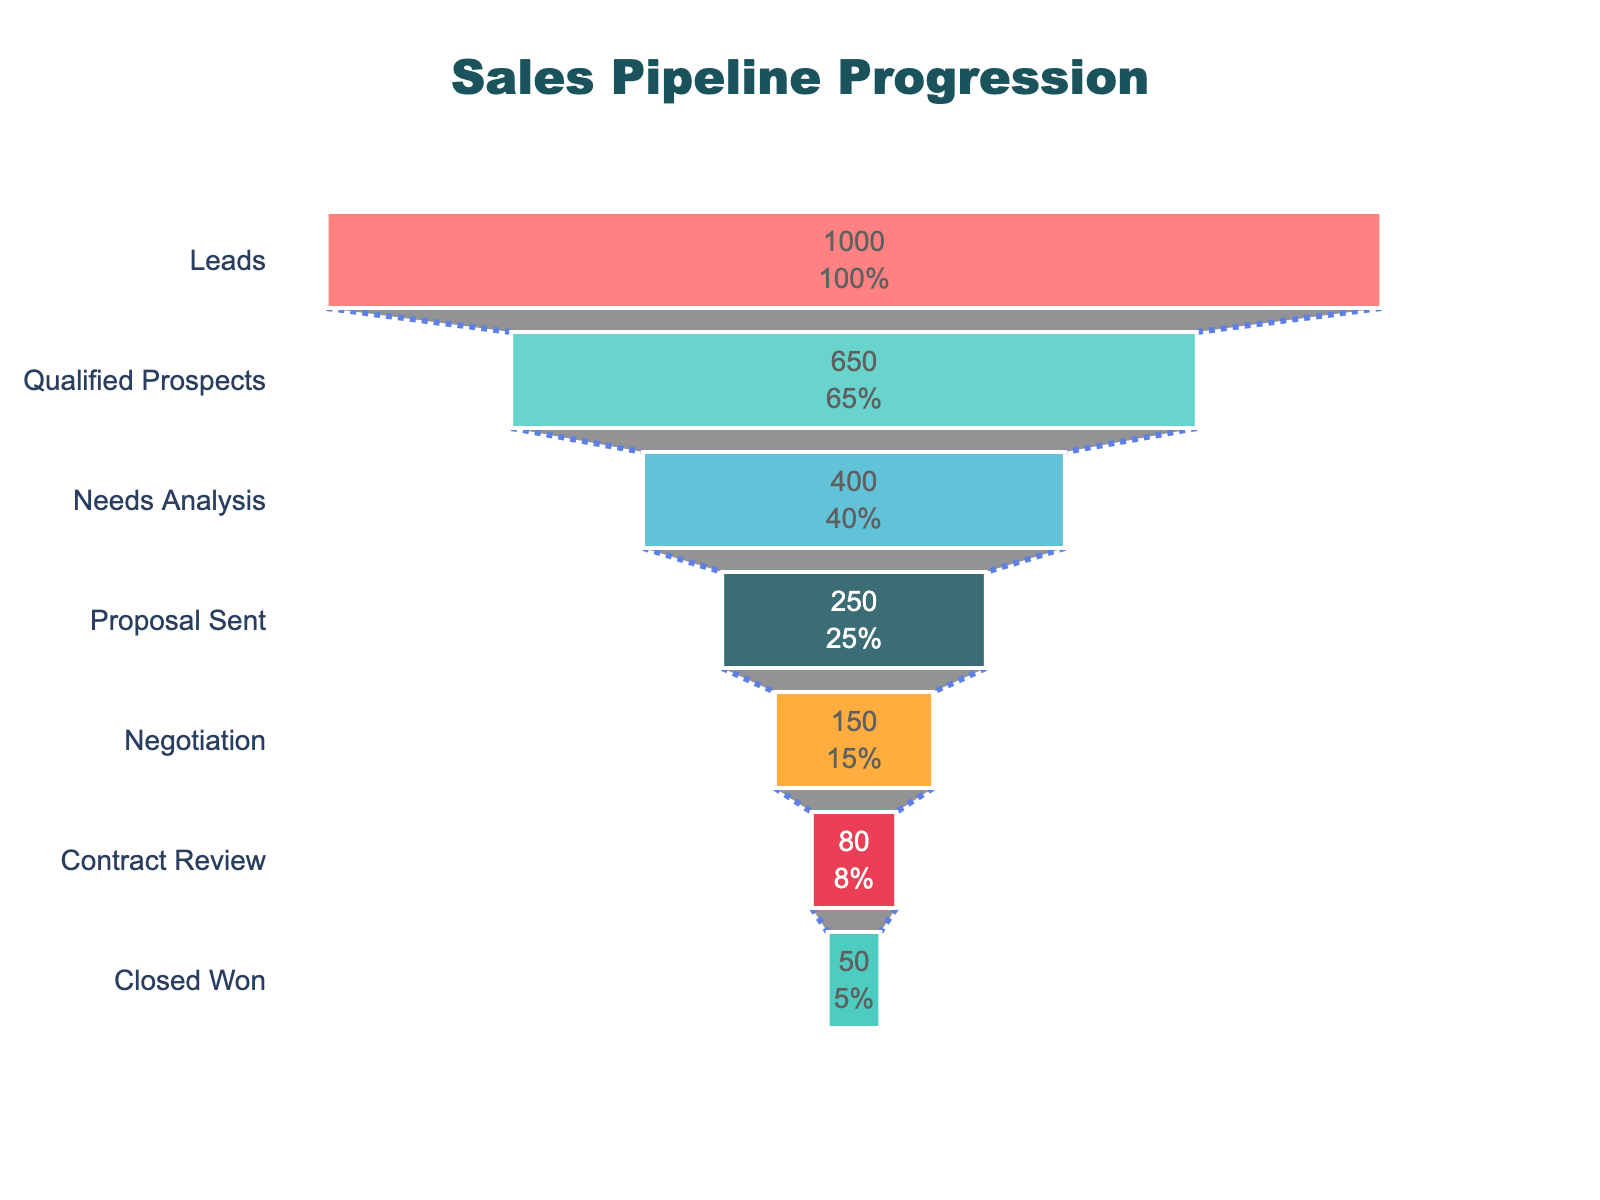What's the title of the chart? To find the title, look at the top section of the chart where the largest text is located. In this case, it says "Sales Pipeline Progression".
Answer: Sales Pipeline Progression How many stages are there in the sales pipeline? Count the number of distinct bars representing each stage in the funnel chart. This chart shows seven stages.
Answer: Seven What percentage of leads become qualified prospects? The chart indicates that 650 out of 1000 leads become qualified prospects. To calculate the percentage: (650 / 1000) * 100% = 65%.
Answer: 65% What is the count at the 'Closed Won' stage? Identify the 'Closed Won' stage on the chart and read the count value, which is shown as 50.
Answer: 50 What’s the drop-off rate from 'Negotiation' to 'Contract Review'? Compare the counts at both stages: Negotiation has 150, and Contract Review has 80. To find the drop-off rate: 1 - (80 / 150) = 0.4667, or 46.67%.
Answer: 46.67% What stage has the largest drop-off from its previous stage? Calculate the percentage drop-off between consecutive stages and find the largest one. The largest drop-off occurs from Leads (1000) to Qualified Prospects (650) with a drop-off of 35% [(1000 - 650) / 1000 * 100].
Answer: 35% What is the total number of transitions made between all stages? Sum up the counts of all individual stages (excluding the first one since Leads is the starting point): 650 + 400 + 250 + 150 + 80 + 50 = 1580.
Answer: 1580 What is the combined percentage of stages after 'Needs Analysis'? Calculate the combined count after 'Needs Analysis' stage: 250 + 150 + 80 + 50 = 530. To find the percentage out of the initial 1000 leads: (530 / 1000) * 100% = 53%.
Answer: 53% At which stage do we lose the highest number of opportunities? Subtract each subsequent stage count from the previous one to find the number of opportunities lost at each stage and identify the maximum. The highest loss is from Leads (1000) to Qualified Prospects (650) with a loss of 350.
Answer: 350 How many more opportunities progress from 'Proposal Sent' compared to 'Needs Analysis'? Compare the counts at both stages: Proposal Sent has 250, and Needs Analysis has 400. The difference: 400 - 250 = 150.
Answer: 150 